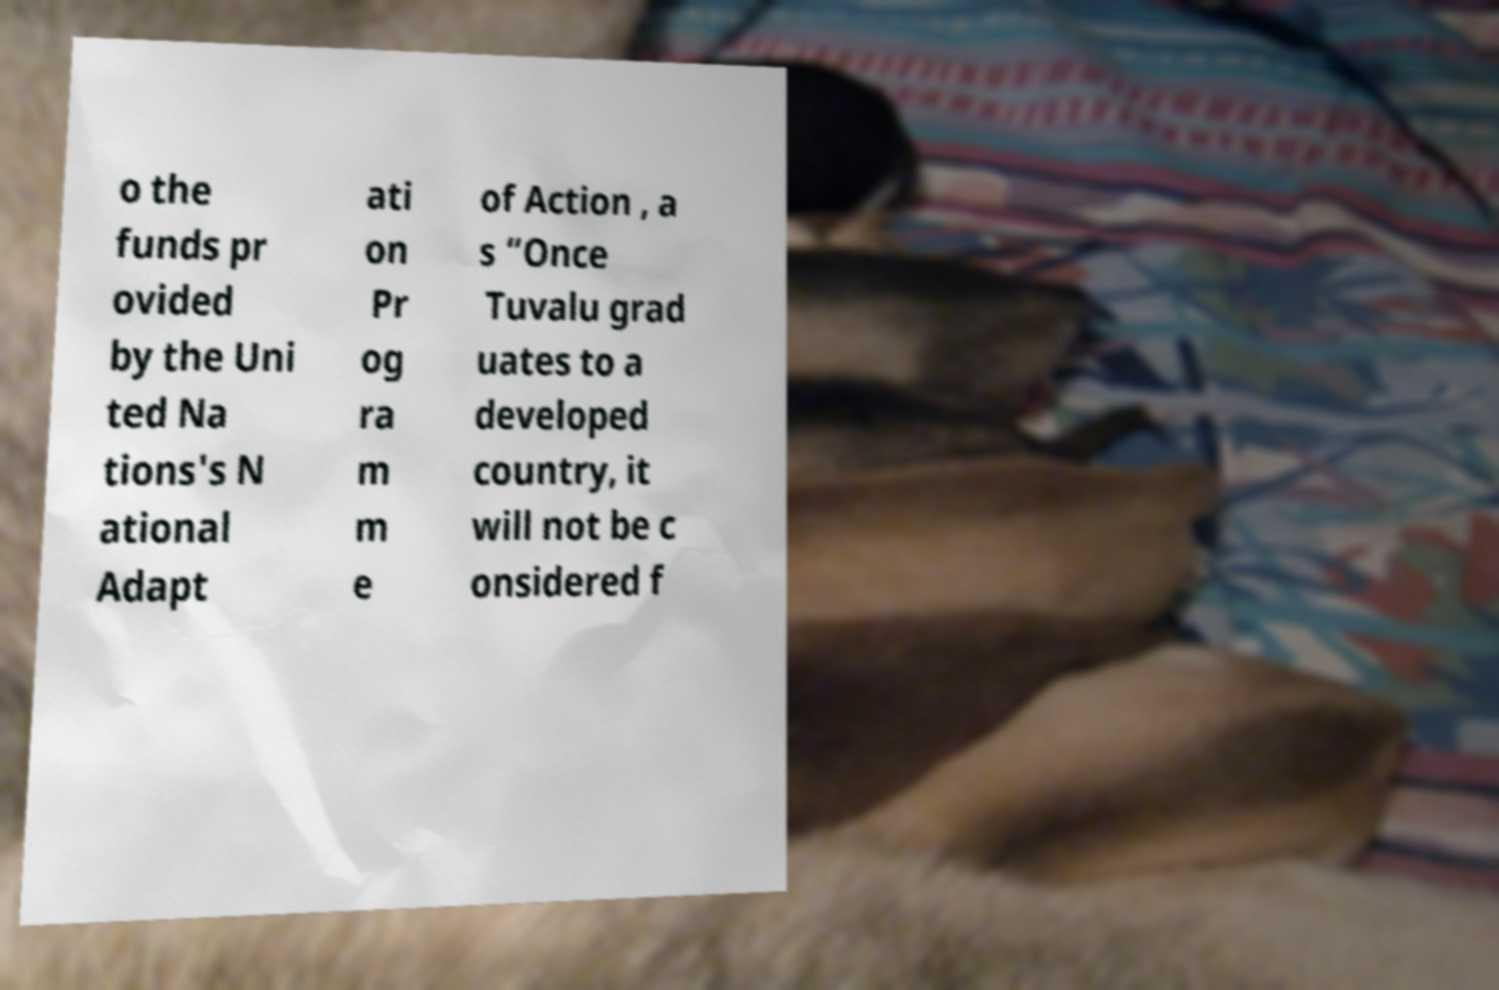There's text embedded in this image that I need extracted. Can you transcribe it verbatim? o the funds pr ovided by the Uni ted Na tions's N ational Adapt ati on Pr og ra m m e of Action , a s “Once Tuvalu grad uates to a developed country, it will not be c onsidered f 